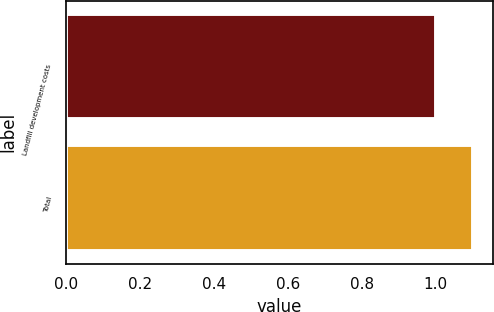Convert chart to OTSL. <chart><loc_0><loc_0><loc_500><loc_500><bar_chart><fcel>Landfill development costs<fcel>Total<nl><fcel>1<fcel>1.1<nl></chart> 